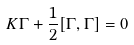<formula> <loc_0><loc_0><loc_500><loc_500>K \Gamma + \frac { 1 } { 2 } [ \Gamma , \Gamma ] = 0</formula> 